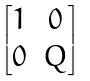Convert formula to latex. <formula><loc_0><loc_0><loc_500><loc_500>\begin{bmatrix} 1 & 0 \\ 0 & Q \end{bmatrix}</formula> 